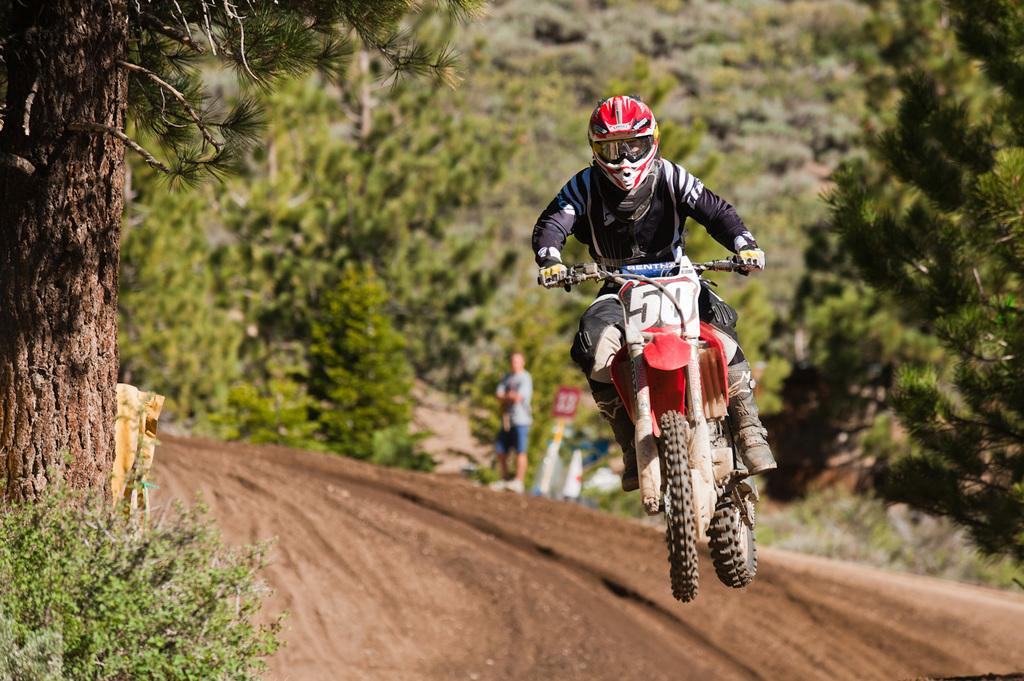What activity is the person in the image engaged in? The person is riding a bike in the image. What safety equipment is the person wearing? The person is wearing a helmet and gloves. What type of vegetation can be seen in the image? There are plants and a tree visible in the image. How would you describe the background of the image? The background is blurry, and there is a person standing in the background, along with trees and a board. How does the person in the image sort the art pieces in the tent? There is no tent or art pieces present in the image; it features a person riding a bike with a blurry background. 